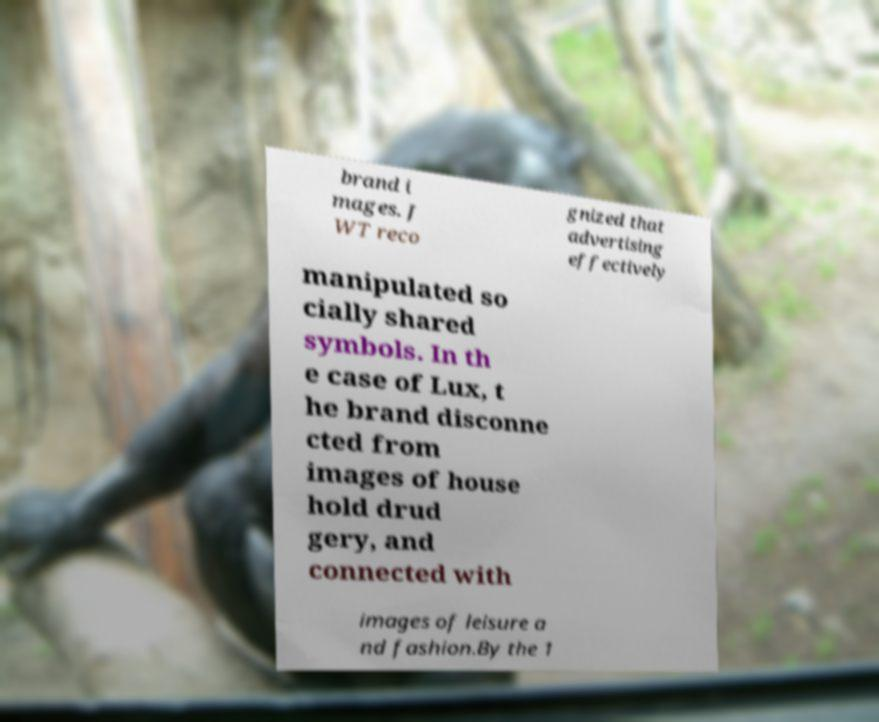Please identify and transcribe the text found in this image. brand i mages. J WT reco gnized that advertising effectively manipulated so cially shared symbols. In th e case of Lux, t he brand disconne cted from images of house hold drud gery, and connected with images of leisure a nd fashion.By the 1 